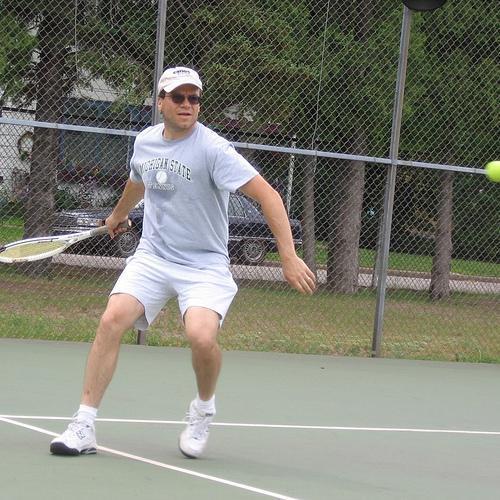How many people are there?
Give a very brief answer. 1. 